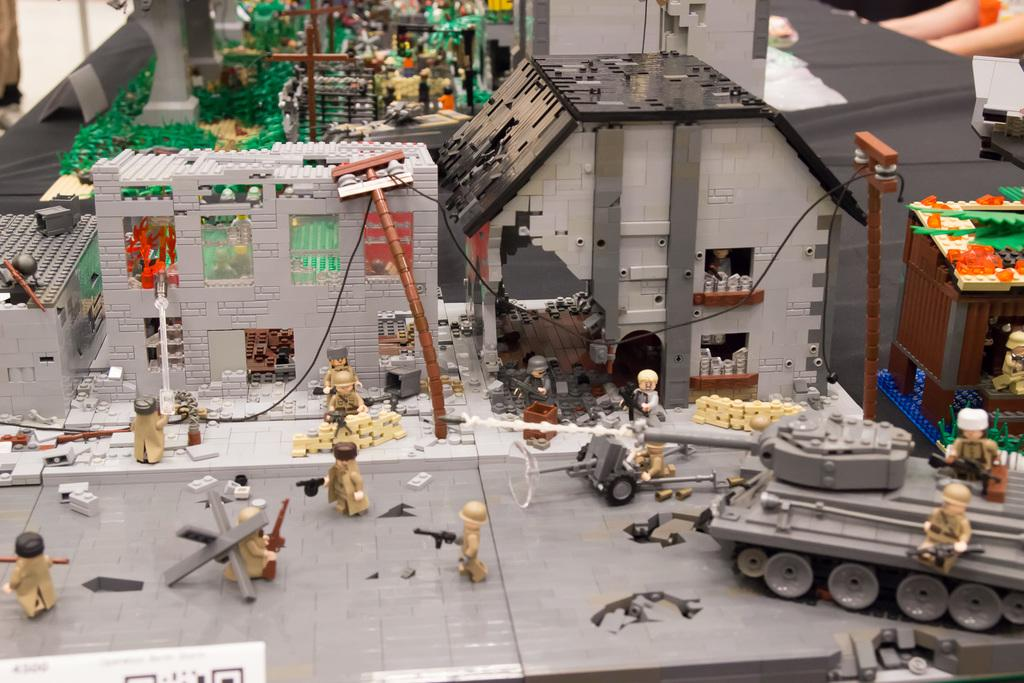What type of structures can be seen in the image? There are houses in the image. What else can be seen in the image related to infrastructure? There are electrical poles and wires in the image. Are there any people present in the image? Yes, there are people in the image. What objects related to conflict are visible in the image? There are weapons in the image. Can you describe the path in the image? There is a path in the image. What type of vehicles can be seen in the image? There is a war tank in the image. What objects are present for recreational purposes? There are playing objects in the image. Can you tell me how many kittens are playing with a pin in the image? There are no kittens or pins present in the image. What type of apparel is being worn by the people in the image? The provided facts do not mention any specific apparel worn by the people in the image. 